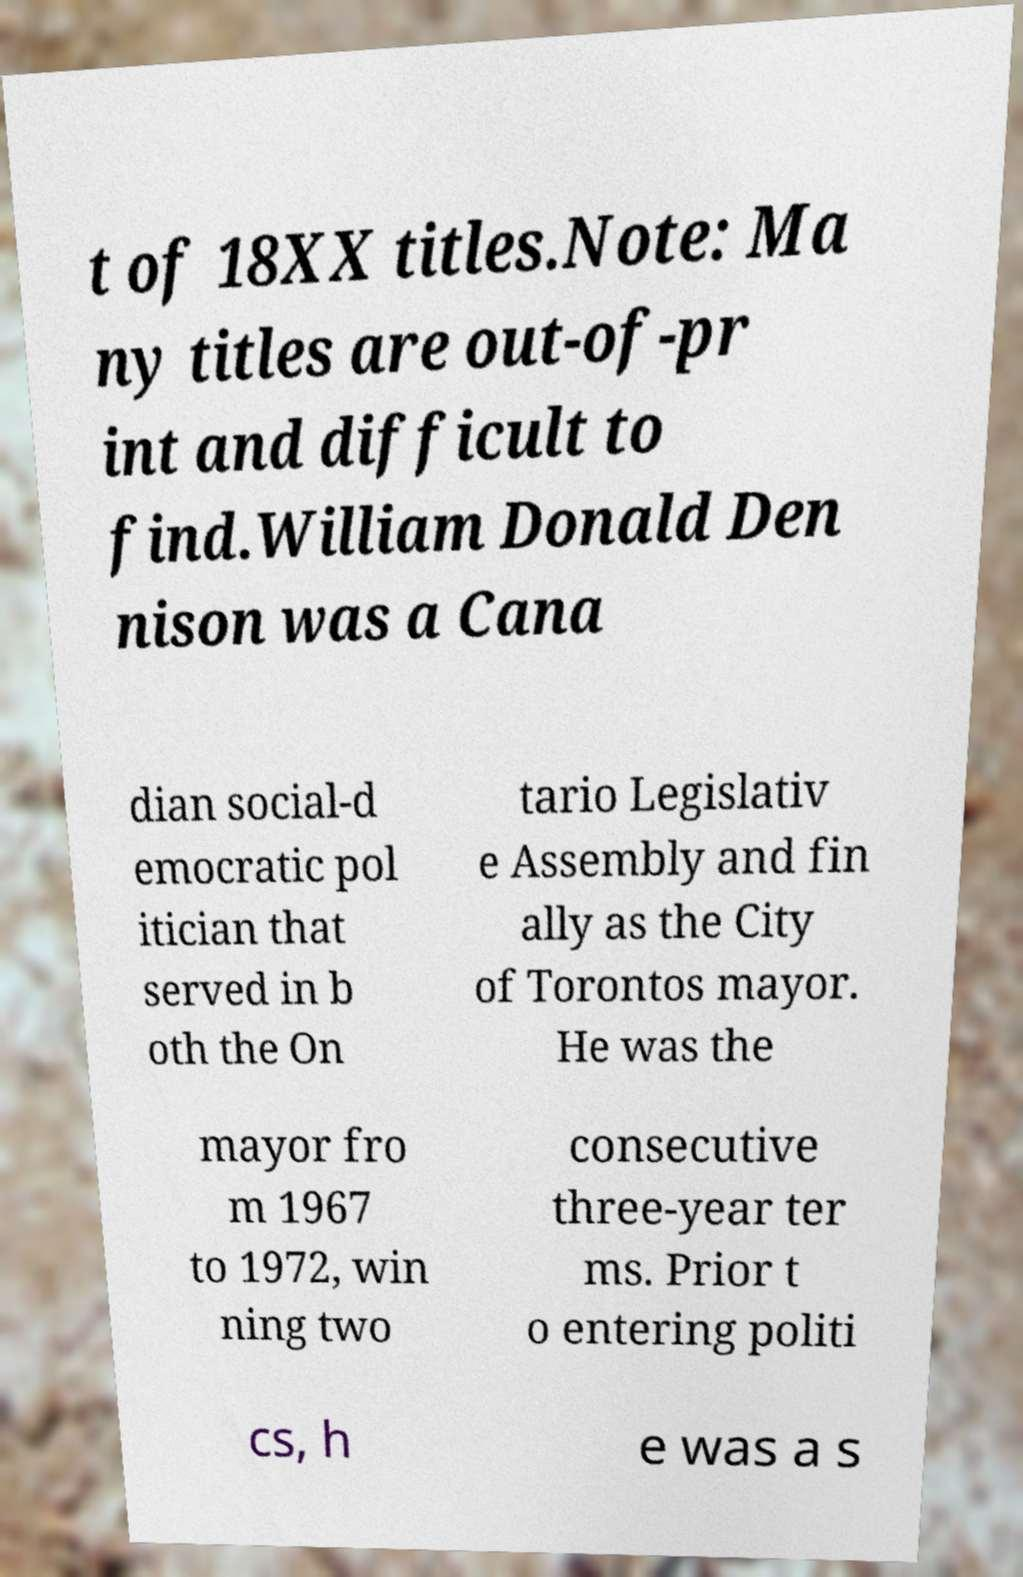Please read and relay the text visible in this image. What does it say? t of 18XX titles.Note: Ma ny titles are out-of-pr int and difficult to find.William Donald Den nison was a Cana dian social-d emocratic pol itician that served in b oth the On tario Legislativ e Assembly and fin ally as the City of Torontos mayor. He was the mayor fro m 1967 to 1972, win ning two consecutive three-year ter ms. Prior t o entering politi cs, h e was a s 